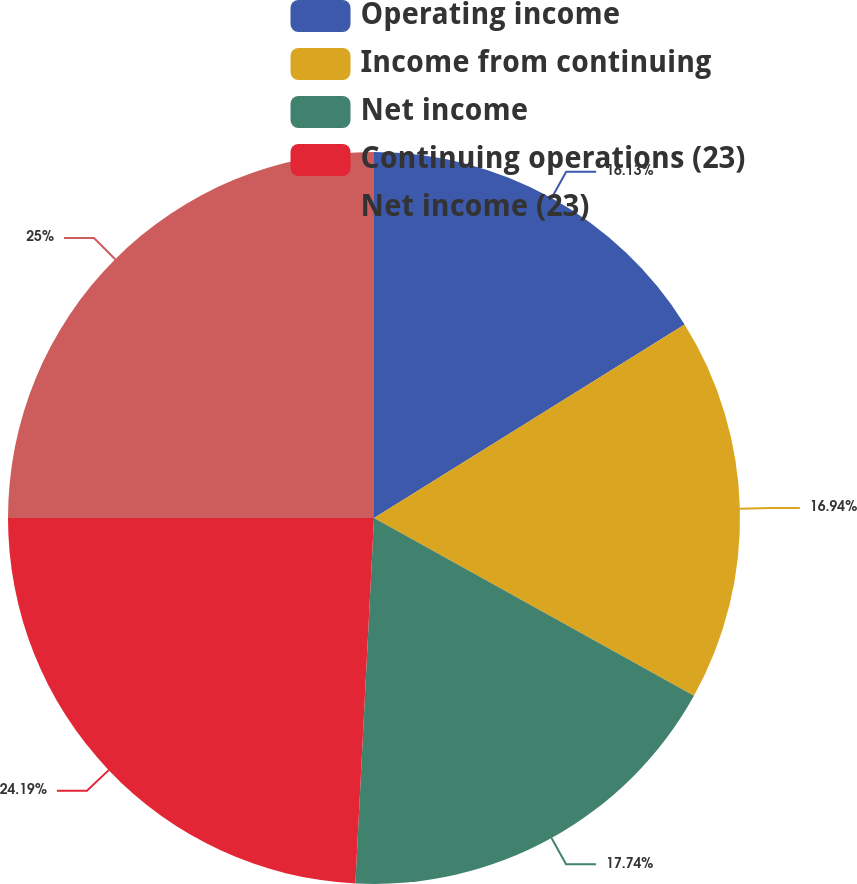Convert chart to OTSL. <chart><loc_0><loc_0><loc_500><loc_500><pie_chart><fcel>Operating income<fcel>Income from continuing<fcel>Net income<fcel>Continuing operations (23)<fcel>Net income (23)<nl><fcel>16.13%<fcel>16.94%<fcel>17.74%<fcel>24.19%<fcel>25.0%<nl></chart> 